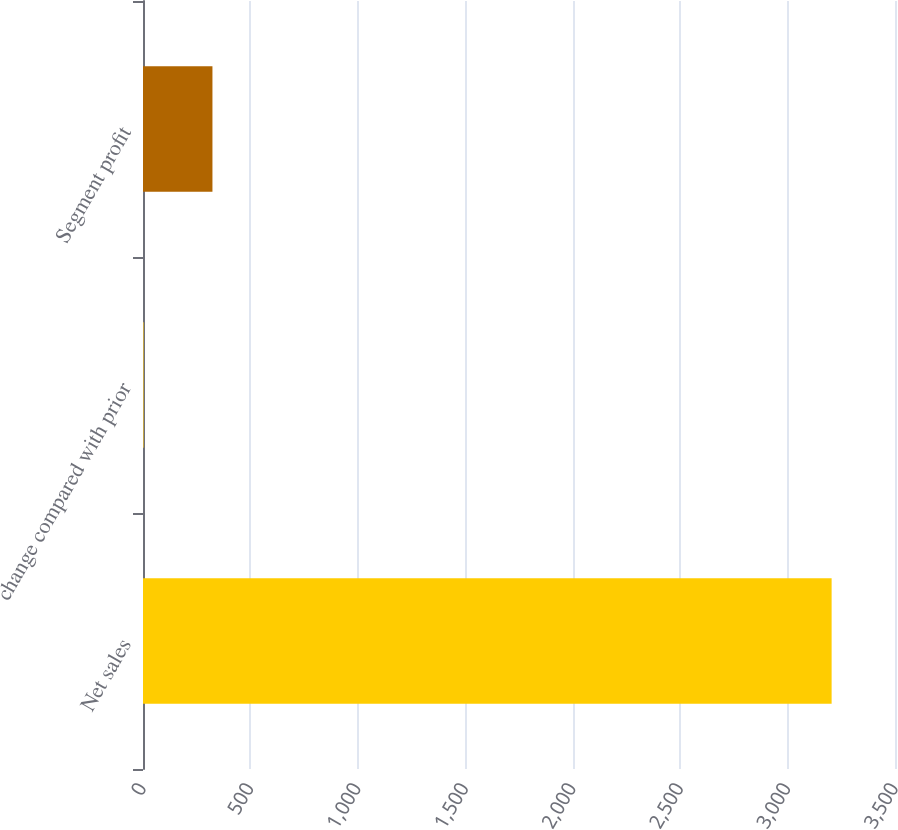Convert chart. <chart><loc_0><loc_0><loc_500><loc_500><bar_chart><fcel>Net sales<fcel>change compared with prior<fcel>Segment profit<nl><fcel>3205<fcel>3<fcel>323.2<nl></chart> 